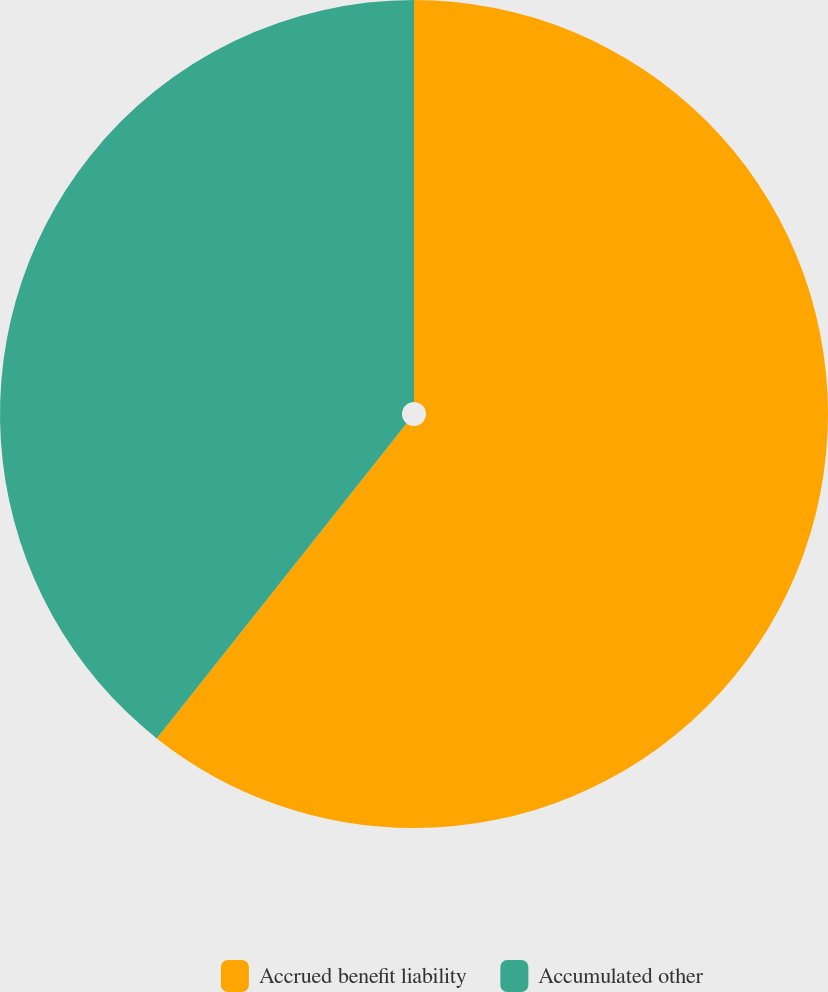Convert chart. <chart><loc_0><loc_0><loc_500><loc_500><pie_chart><fcel>Accrued benefit liability<fcel>Accumulated other<nl><fcel>60.67%<fcel>39.33%<nl></chart> 